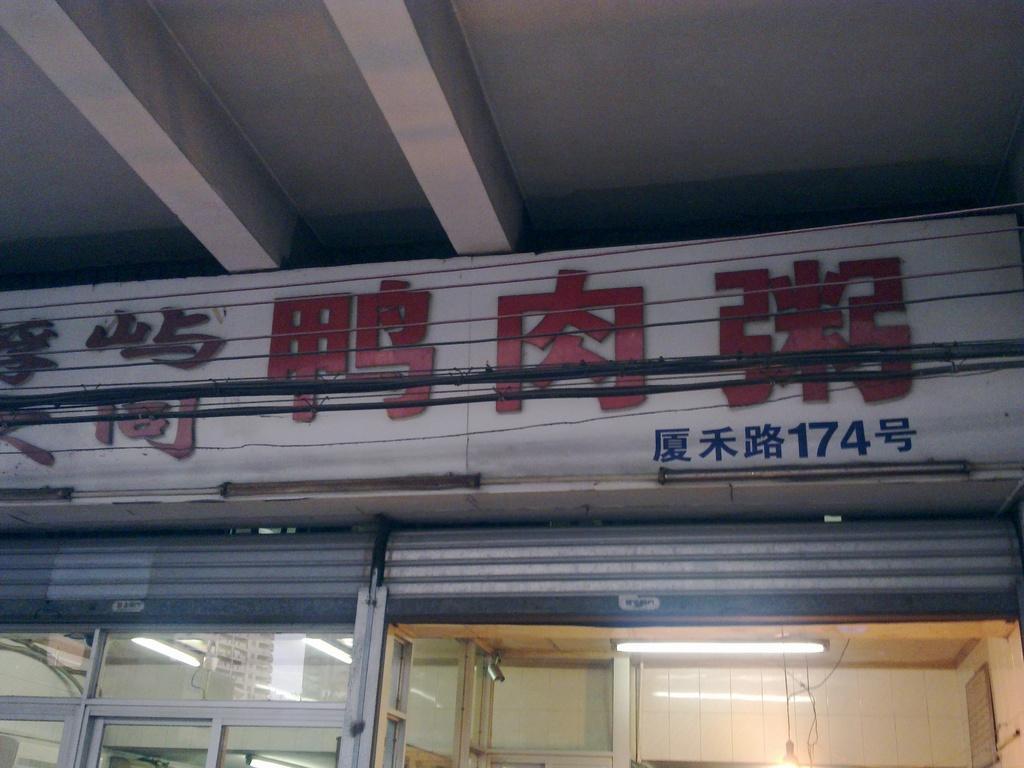Describe this image in one or two sentences. In this picture we can see few cables, a hoarding, few lights, rolling shutters and glasses, and also we can see a camera. 